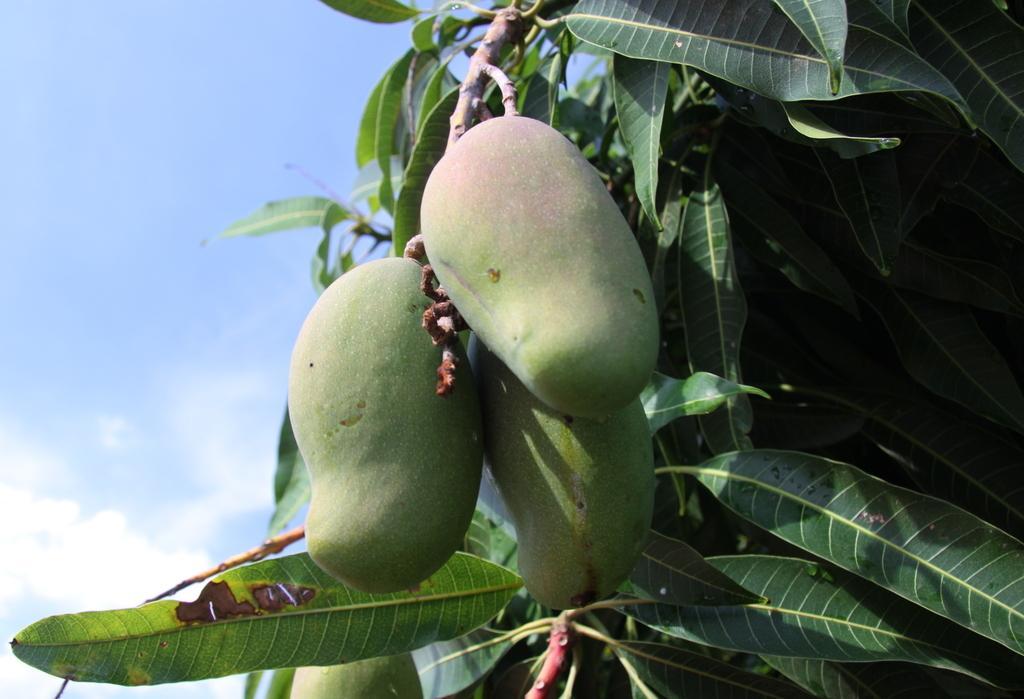How would you summarize this image in a sentence or two? In this image we can see a tree. There are few mangoes to a tree. There is a blue and a slightly cloudy sky in the image. 